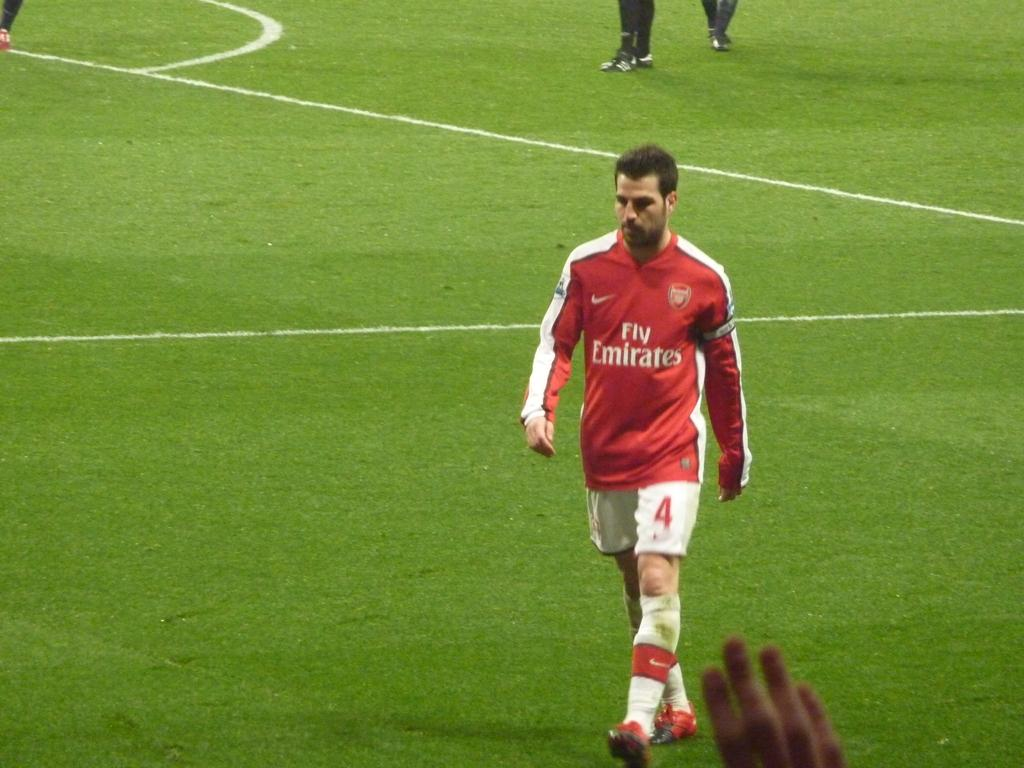What is the person in the image doing? There is a person walking in the image. What is the person wearing? The person is wearing a white and red color dress. What type of footwear is the person wearing? The person is wearing shoes. What can be seen in the background of the image? There are people present in a garden in the background of the image. What color is the shirt worn by the person in the image? There is no shirt mentioned in the facts; the person is wearing a white and red color dress. How does the person burst into flames in the image? There is no indication in the image that the person is on fire or bursting into flames. 